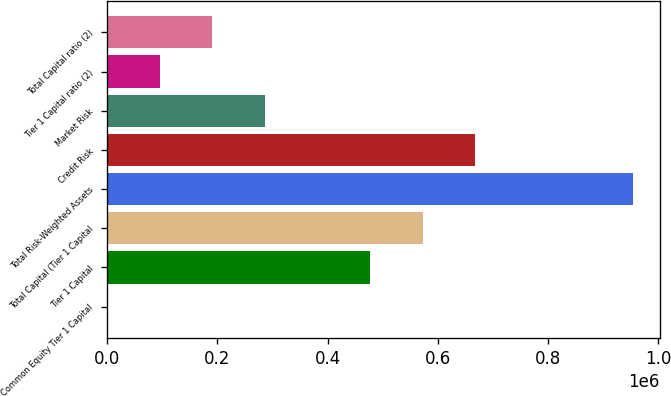<chart> <loc_0><loc_0><loc_500><loc_500><bar_chart><fcel>Common Equity Tier 1 Capital<fcel>Tier 1 Capital<fcel>Total Capital (Tier 1 Capital<fcel>Total Risk-Weighted Assets<fcel>Credit Risk<fcel>Market Risk<fcel>Tier 1 Capital ratio (2)<fcel>Total Capital ratio (2)<nl><fcel>13.07<fcel>477286<fcel>572741<fcel>954559<fcel>668195<fcel>286377<fcel>95467.7<fcel>190922<nl></chart> 